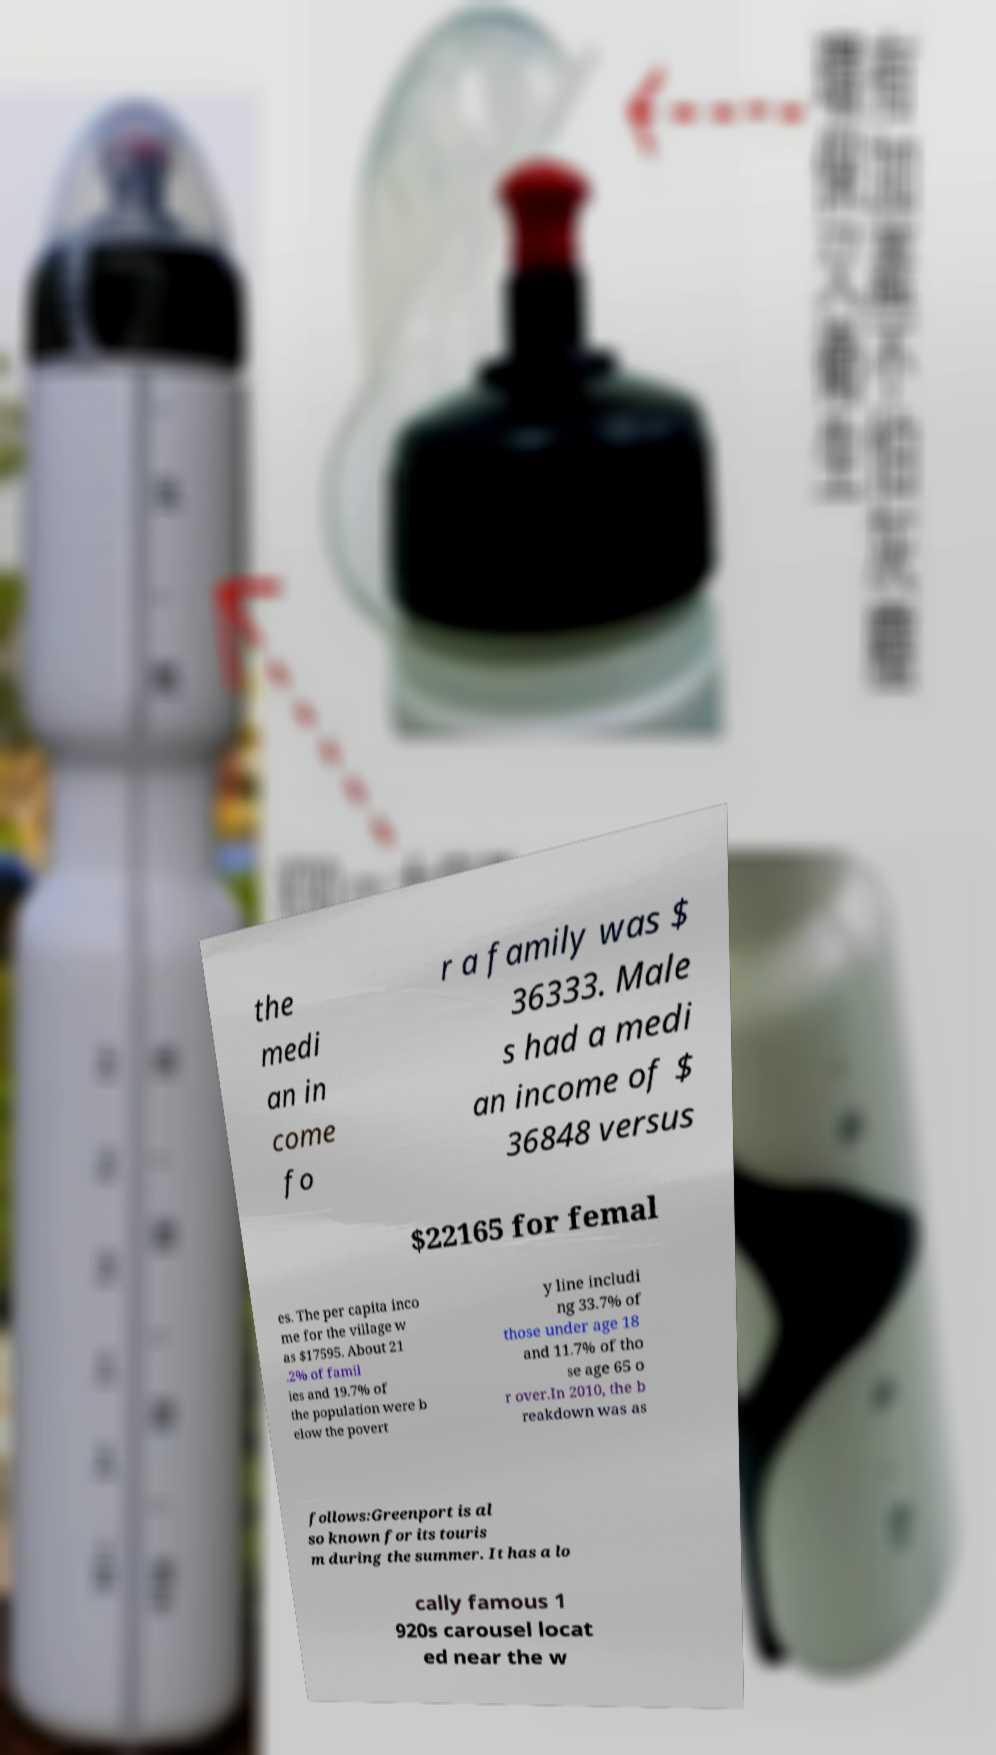For documentation purposes, I need the text within this image transcribed. Could you provide that? the medi an in come fo r a family was $ 36333. Male s had a medi an income of $ 36848 versus $22165 for femal es. The per capita inco me for the village w as $17595. About 21 .2% of famil ies and 19.7% of the population were b elow the povert y line includi ng 33.7% of those under age 18 and 11.7% of tho se age 65 o r over.In 2010, the b reakdown was as follows:Greenport is al so known for its touris m during the summer. It has a lo cally famous 1 920s carousel locat ed near the w 